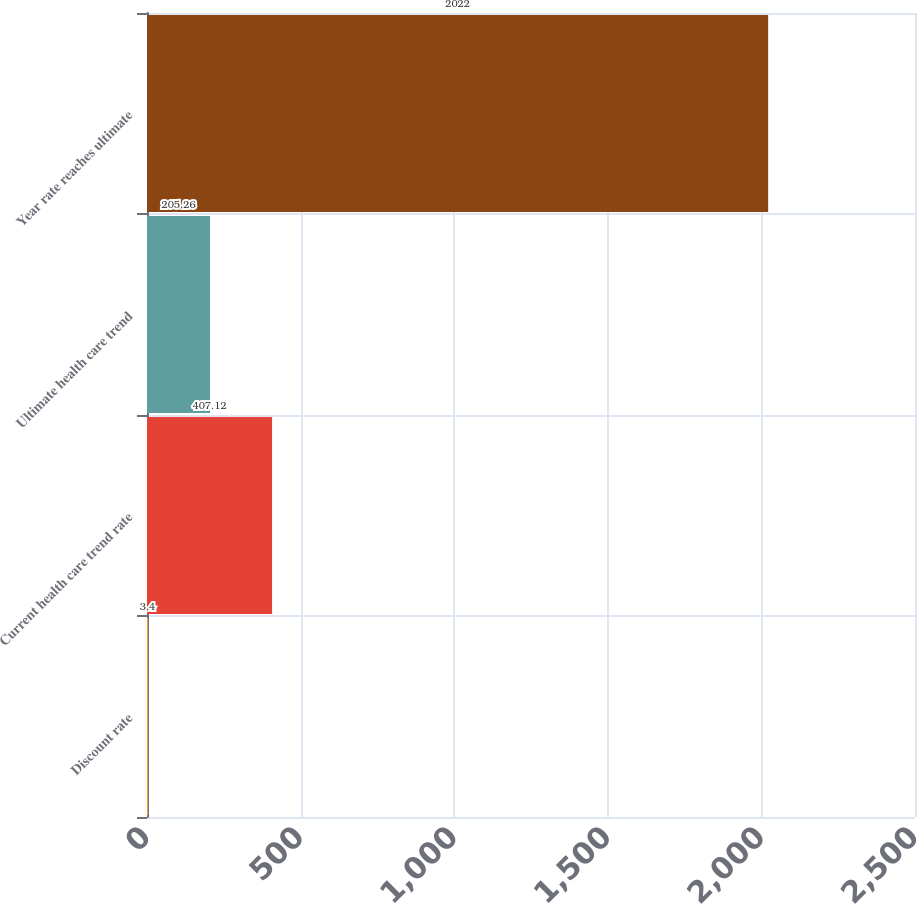Convert chart. <chart><loc_0><loc_0><loc_500><loc_500><bar_chart><fcel>Discount rate<fcel>Current health care trend rate<fcel>Ultimate health care trend<fcel>Year rate reaches ultimate<nl><fcel>3.4<fcel>407.12<fcel>205.26<fcel>2022<nl></chart> 